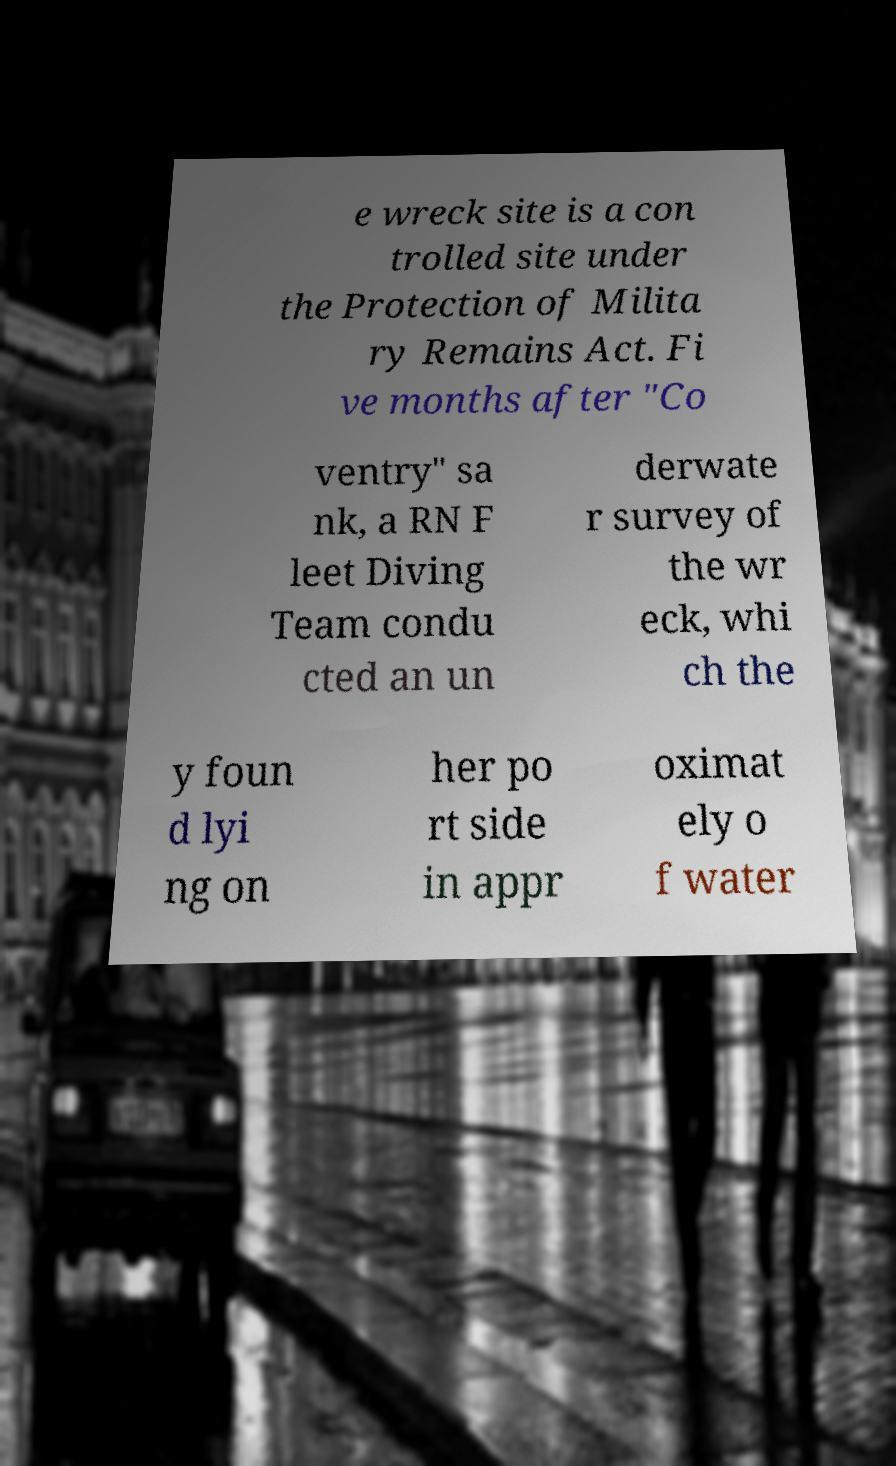Can you accurately transcribe the text from the provided image for me? e wreck site is a con trolled site under the Protection of Milita ry Remains Act. Fi ve months after "Co ventry" sa nk, a RN F leet Diving Team condu cted an un derwate r survey of the wr eck, whi ch the y foun d lyi ng on her po rt side in appr oximat ely o f water 